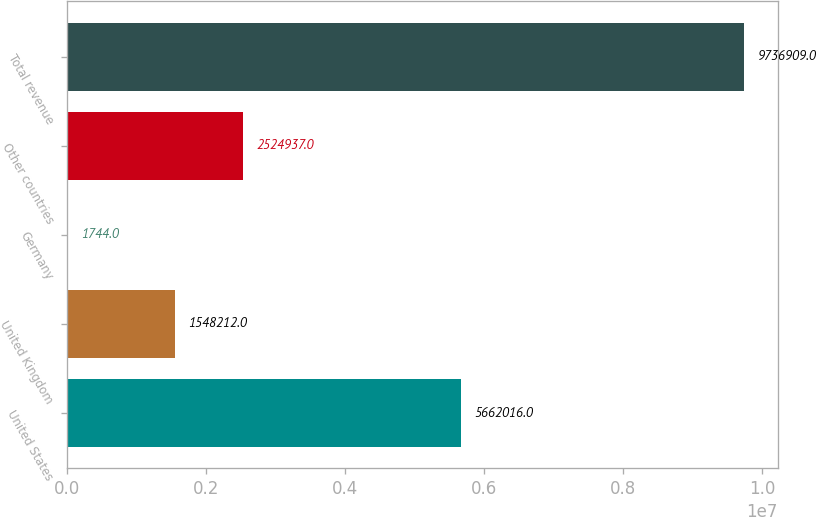Convert chart. <chart><loc_0><loc_0><loc_500><loc_500><bar_chart><fcel>United States<fcel>United Kingdom<fcel>Germany<fcel>Other countries<fcel>Total revenue<nl><fcel>5.66202e+06<fcel>1.54821e+06<fcel>1744<fcel>2.52494e+06<fcel>9.73691e+06<nl></chart> 